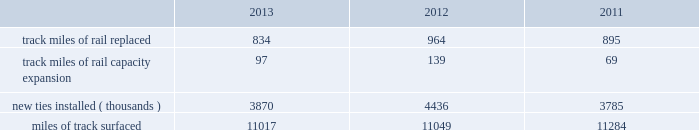2013 2012 2011 .
Capital plan 2013 in 2014 , we expect our total capital investments to be approximately $ 3.9 billion , which may be revised if business conditions or the regulatory environment affect our ability to generate sufficient returns on these investments .
While the number of our assets replaced will fluctuate as part of our replacement strategy , for 2014 we expect to use over 60% ( 60 % ) of our capital investments to replace and improve existing capital assets .
Among our major investment categories are replacing and improving track infrastructure and upgrading our locomotive , freight car and container fleets , including the acquisition of 200 locomotives .
Additionally , we will continue increasing our network and terminal capacity , especially in the southern region , and balancing terminal capacity with more mainline capacity .
Construction of a major rail facility at santa teresa , new mexico , will be completed in 2014 and will include a run-through and fueling facility as well as an intermodal ramp .
We also plan to make significant investments in technology improvements , including approximately $ 450 million for ptc .
We expect to fund our 2014 cash capital investments by using some or all of the following : cash generated from operations , proceeds from the sale or lease of various operating and non-operating properties , proceeds from the issuance of long-term debt , and cash on hand .
Our annual capital plan is a critical component of our long-term strategic plan , which we expect will enhance the long-term value of the corporation for our shareholders by providing sufficient resources to ( i ) replace and improve our existing track infrastructure to provide safe and fluid operations , ( ii ) increase network efficiency by adding or improving facilities and track , and ( iii ) make investments that meet customer demand and take advantage of opportunities for long-term growth .
Financing activities cash used in financing activities increased in 2013 versus 2012 , driven by a $ 744 million increase for the repurchase of shares under our common stock repurchase program and higher dividend payments in 2013 of $ 1.3 billion compared to $ 1.1 billion in 2012 .
We increased our debt levels in 2013 , which partially offset the increase in cash used in financing activities .
Cash used in financing activities increased in 2012 versus 2011 .
Dividend payments in 2012 increased by $ 309 million , reflecting our higher dividend rate , and common stock repurchases increased by $ 56 million .
Our debt levels did not materially change from 2011 after a decline in debt levels from 2010 .
Therefore , less cash was used in 2012 for debt activity than in 2011 .
Dividends 2013 on february 6 , 2014 , we increased the quarterly dividend to $ 0.91 per share , payable on april 1 , 2014 , to shareholders of record on february 28 , 2014 .
We expect to fund the increase in the quarterly dividend through cash generated from operations and cash on hand at december 31 , 2013 .
Credit facilities 2013 on december 31 , 2013 , we had $ 1.8 billion of credit available under our revolving credit facility ( the facility ) , which is designated for general corporate purposes and supports the issuance of commercial paper .
We did not draw on the facility during 2013 .
Commitment fees and interest rates payable under the facility are similar to fees and rates available to comparably rated , investment-grade borrowers .
The facility allows for borrowings at floating rates based on london interbank offered rates , plus a spread , depending upon credit ratings for our senior unsecured debt .
The facility matures in 2015 under a four year term and requires the corporation to maintain a debt-to-net-worth coverage ratio as a condition to making a borrowing .
At december 31 , 2013 , and december 31 , 2012 ( and at all times during the year ) , we were in compliance with this covenant .
The definition of debt used for purposes of calculating the debt-to-net-worth coverage ratio includes , among other things , certain credit arrangements , capital leases , guarantees and unfunded and vested pension benefits under title iv of erisa .
At december 31 , 2013 , the debt-to-net-worth coverage ratio allowed us to carry up to $ 42.4 billion of debt ( as defined in the facility ) , and we had $ 9.9 billion of debt ( as defined in the facility ) outstanding at that date .
Under our current capital plans , we expect to continue to satisfy the debt-to-net-worth coverage ratio ; however , many factors beyond our reasonable control .
In 2013 what was the ratio of the track miles of rail replaced to the capacity expansion? 
Computations: (834 / 97)
Answer: 8.59794. 2013 2012 2011 .
Capital plan 2013 in 2014 , we expect our total capital investments to be approximately $ 3.9 billion , which may be revised if business conditions or the regulatory environment affect our ability to generate sufficient returns on these investments .
While the number of our assets replaced will fluctuate as part of our replacement strategy , for 2014 we expect to use over 60% ( 60 % ) of our capital investments to replace and improve existing capital assets .
Among our major investment categories are replacing and improving track infrastructure and upgrading our locomotive , freight car and container fleets , including the acquisition of 200 locomotives .
Additionally , we will continue increasing our network and terminal capacity , especially in the southern region , and balancing terminal capacity with more mainline capacity .
Construction of a major rail facility at santa teresa , new mexico , will be completed in 2014 and will include a run-through and fueling facility as well as an intermodal ramp .
We also plan to make significant investments in technology improvements , including approximately $ 450 million for ptc .
We expect to fund our 2014 cash capital investments by using some or all of the following : cash generated from operations , proceeds from the sale or lease of various operating and non-operating properties , proceeds from the issuance of long-term debt , and cash on hand .
Our annual capital plan is a critical component of our long-term strategic plan , which we expect will enhance the long-term value of the corporation for our shareholders by providing sufficient resources to ( i ) replace and improve our existing track infrastructure to provide safe and fluid operations , ( ii ) increase network efficiency by adding or improving facilities and track , and ( iii ) make investments that meet customer demand and take advantage of opportunities for long-term growth .
Financing activities cash used in financing activities increased in 2013 versus 2012 , driven by a $ 744 million increase for the repurchase of shares under our common stock repurchase program and higher dividend payments in 2013 of $ 1.3 billion compared to $ 1.1 billion in 2012 .
We increased our debt levels in 2013 , which partially offset the increase in cash used in financing activities .
Cash used in financing activities increased in 2012 versus 2011 .
Dividend payments in 2012 increased by $ 309 million , reflecting our higher dividend rate , and common stock repurchases increased by $ 56 million .
Our debt levels did not materially change from 2011 after a decline in debt levels from 2010 .
Therefore , less cash was used in 2012 for debt activity than in 2011 .
Dividends 2013 on february 6 , 2014 , we increased the quarterly dividend to $ 0.91 per share , payable on april 1 , 2014 , to shareholders of record on february 28 , 2014 .
We expect to fund the increase in the quarterly dividend through cash generated from operations and cash on hand at december 31 , 2013 .
Credit facilities 2013 on december 31 , 2013 , we had $ 1.8 billion of credit available under our revolving credit facility ( the facility ) , which is designated for general corporate purposes and supports the issuance of commercial paper .
We did not draw on the facility during 2013 .
Commitment fees and interest rates payable under the facility are similar to fees and rates available to comparably rated , investment-grade borrowers .
The facility allows for borrowings at floating rates based on london interbank offered rates , plus a spread , depending upon credit ratings for our senior unsecured debt .
The facility matures in 2015 under a four year term and requires the corporation to maintain a debt-to-net-worth coverage ratio as a condition to making a borrowing .
At december 31 , 2013 , and december 31 , 2012 ( and at all times during the year ) , we were in compliance with this covenant .
The definition of debt used for purposes of calculating the debt-to-net-worth coverage ratio includes , among other things , certain credit arrangements , capital leases , guarantees and unfunded and vested pension benefits under title iv of erisa .
At december 31 , 2013 , the debt-to-net-worth coverage ratio allowed us to carry up to $ 42.4 billion of debt ( as defined in the facility ) , and we had $ 9.9 billion of debt ( as defined in the facility ) outstanding at that date .
Under our current capital plans , we expect to continue to satisfy the debt-to-net-worth coverage ratio ; however , many factors beyond our reasonable control .
What was the difference in track miles of rail replaced between 2012 and 2013? 
Computations: (834 - 964)
Answer: -130.0. 2013 2012 2011 .
Capital plan 2013 in 2014 , we expect our total capital investments to be approximately $ 3.9 billion , which may be revised if business conditions or the regulatory environment affect our ability to generate sufficient returns on these investments .
While the number of our assets replaced will fluctuate as part of our replacement strategy , for 2014 we expect to use over 60% ( 60 % ) of our capital investments to replace and improve existing capital assets .
Among our major investment categories are replacing and improving track infrastructure and upgrading our locomotive , freight car and container fleets , including the acquisition of 200 locomotives .
Additionally , we will continue increasing our network and terminal capacity , especially in the southern region , and balancing terminal capacity with more mainline capacity .
Construction of a major rail facility at santa teresa , new mexico , will be completed in 2014 and will include a run-through and fueling facility as well as an intermodal ramp .
We also plan to make significant investments in technology improvements , including approximately $ 450 million for ptc .
We expect to fund our 2014 cash capital investments by using some or all of the following : cash generated from operations , proceeds from the sale or lease of various operating and non-operating properties , proceeds from the issuance of long-term debt , and cash on hand .
Our annual capital plan is a critical component of our long-term strategic plan , which we expect will enhance the long-term value of the corporation for our shareholders by providing sufficient resources to ( i ) replace and improve our existing track infrastructure to provide safe and fluid operations , ( ii ) increase network efficiency by adding or improving facilities and track , and ( iii ) make investments that meet customer demand and take advantage of opportunities for long-term growth .
Financing activities cash used in financing activities increased in 2013 versus 2012 , driven by a $ 744 million increase for the repurchase of shares under our common stock repurchase program and higher dividend payments in 2013 of $ 1.3 billion compared to $ 1.1 billion in 2012 .
We increased our debt levels in 2013 , which partially offset the increase in cash used in financing activities .
Cash used in financing activities increased in 2012 versus 2011 .
Dividend payments in 2012 increased by $ 309 million , reflecting our higher dividend rate , and common stock repurchases increased by $ 56 million .
Our debt levels did not materially change from 2011 after a decline in debt levels from 2010 .
Therefore , less cash was used in 2012 for debt activity than in 2011 .
Dividends 2013 on february 6 , 2014 , we increased the quarterly dividend to $ 0.91 per share , payable on april 1 , 2014 , to shareholders of record on february 28 , 2014 .
We expect to fund the increase in the quarterly dividend through cash generated from operations and cash on hand at december 31 , 2013 .
Credit facilities 2013 on december 31 , 2013 , we had $ 1.8 billion of credit available under our revolving credit facility ( the facility ) , which is designated for general corporate purposes and supports the issuance of commercial paper .
We did not draw on the facility during 2013 .
Commitment fees and interest rates payable under the facility are similar to fees and rates available to comparably rated , investment-grade borrowers .
The facility allows for borrowings at floating rates based on london interbank offered rates , plus a spread , depending upon credit ratings for our senior unsecured debt .
The facility matures in 2015 under a four year term and requires the corporation to maintain a debt-to-net-worth coverage ratio as a condition to making a borrowing .
At december 31 , 2013 , and december 31 , 2012 ( and at all times during the year ) , we were in compliance with this covenant .
The definition of debt used for purposes of calculating the debt-to-net-worth coverage ratio includes , among other things , certain credit arrangements , capital leases , guarantees and unfunded and vested pension benefits under title iv of erisa .
At december 31 , 2013 , the debt-to-net-worth coverage ratio allowed us to carry up to $ 42.4 billion of debt ( as defined in the facility ) , and we had $ 9.9 billion of debt ( as defined in the facility ) outstanding at that date .
Under our current capital plans , we expect to continue to satisfy the debt-to-net-worth coverage ratio ; however , many factors beyond our reasonable control .
What was the difference in track miles of rail replaced between 2011 and 2012? 
Computations: (964 - 895)
Answer: 69.0. 